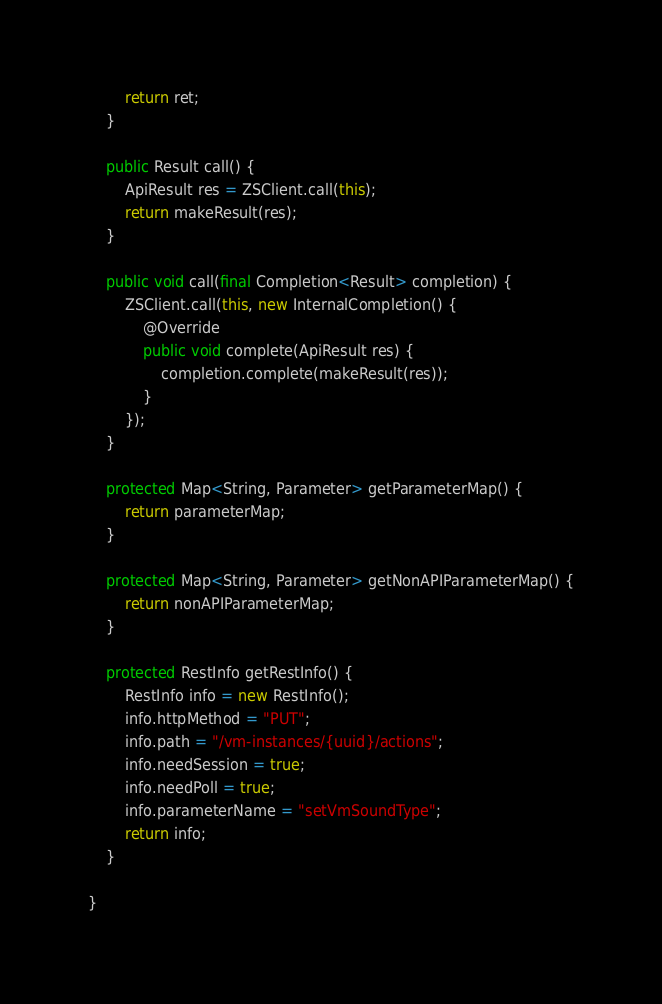Convert code to text. <code><loc_0><loc_0><loc_500><loc_500><_Java_>
        return ret;
    }

    public Result call() {
        ApiResult res = ZSClient.call(this);
        return makeResult(res);
    }

    public void call(final Completion<Result> completion) {
        ZSClient.call(this, new InternalCompletion() {
            @Override
            public void complete(ApiResult res) {
                completion.complete(makeResult(res));
            }
        });
    }

    protected Map<String, Parameter> getParameterMap() {
        return parameterMap;
    }

    protected Map<String, Parameter> getNonAPIParameterMap() {
        return nonAPIParameterMap;
    }

    protected RestInfo getRestInfo() {
        RestInfo info = new RestInfo();
        info.httpMethod = "PUT";
        info.path = "/vm-instances/{uuid}/actions";
        info.needSession = true;
        info.needPoll = true;
        info.parameterName = "setVmSoundType";
        return info;
    }

}
</code> 